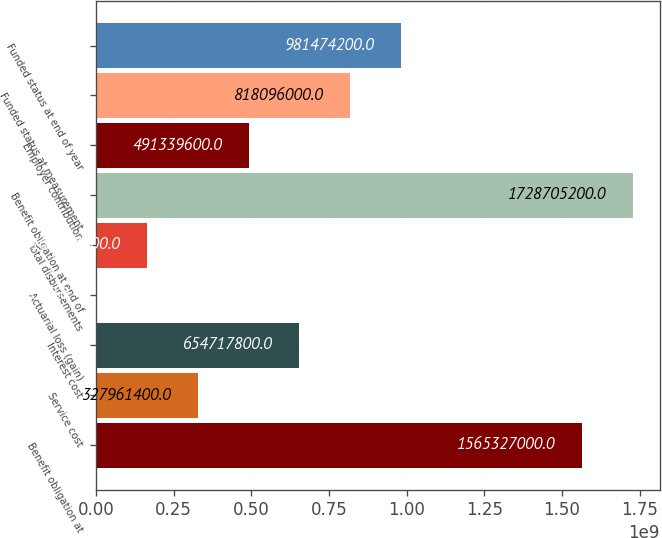<chart> <loc_0><loc_0><loc_500><loc_500><bar_chart><fcel>Benefit obligation at<fcel>Service cost<fcel>Interest cost<fcel>Actuarial loss (gain)<fcel>Total disbursements<fcel>Benefit obligation at end of<fcel>Employer contribution<fcel>Funded status at measurement<fcel>Funded status at end of year<nl><fcel>1.56533e+09<fcel>3.27961e+08<fcel>6.54718e+08<fcel>1.205e+06<fcel>1.64583e+08<fcel>1.72871e+09<fcel>4.9134e+08<fcel>8.18096e+08<fcel>9.81474e+08<nl></chart> 